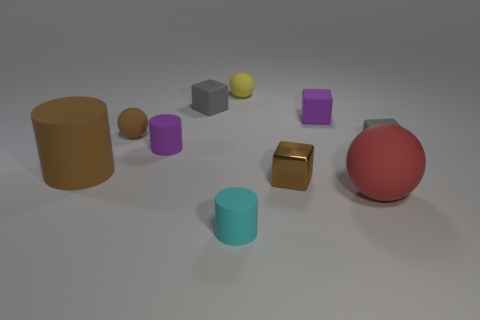Subtract all balls. How many objects are left? 7 Subtract all tiny brown matte things. Subtract all purple rubber cubes. How many objects are left? 8 Add 4 small purple rubber objects. How many small purple rubber objects are left? 6 Add 5 tiny brown matte spheres. How many tiny brown matte spheres exist? 6 Subtract 0 yellow cylinders. How many objects are left? 10 